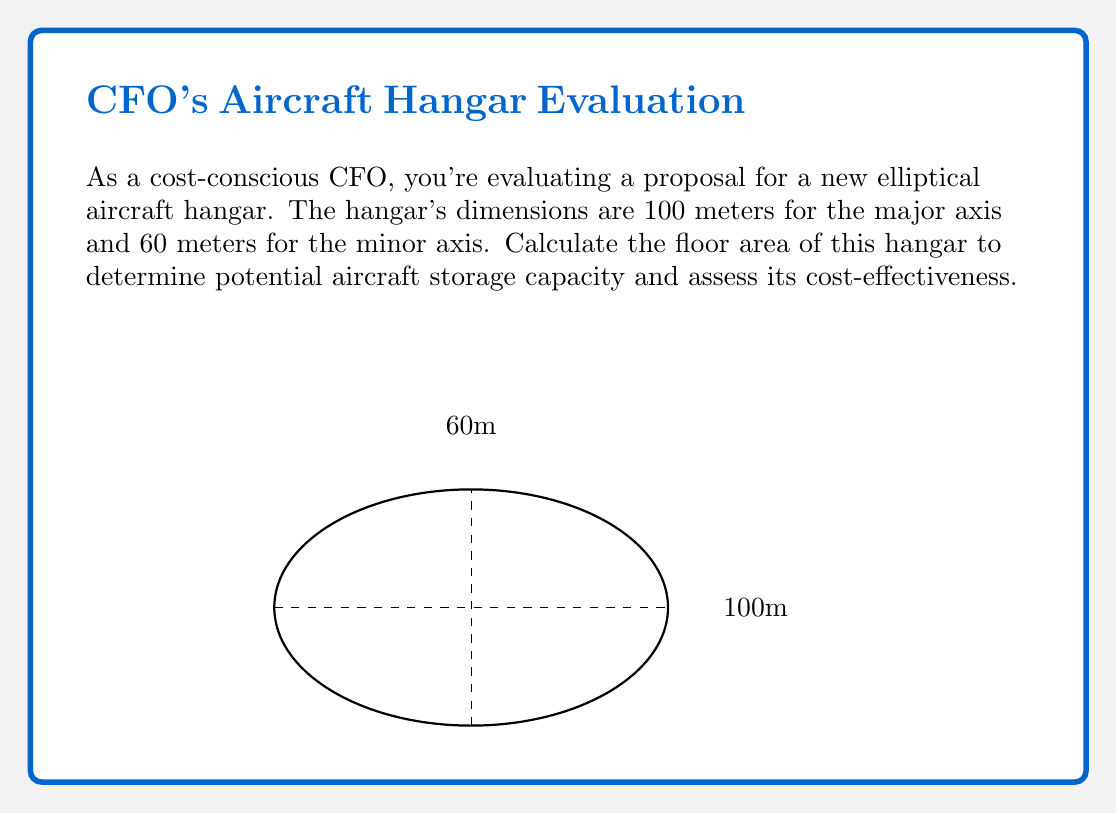Could you help me with this problem? To calculate the area of an ellipse, we use the formula:

$$A = \pi ab$$

Where:
$A$ is the area
$a$ is half the length of the major axis
$b$ is half the length of the minor axis
$\pi$ is approximately 3.14159

Step 1: Identify the values for $a$ and $b$:
$a = 100 \div 2 = 50$ meters
$b = 60 \div 2 = 30$ meters

Step 2: Substitute these values into the formula:
$$A = \pi \cdot 50 \cdot 30$$

Step 3: Calculate:
$$A = 3.14159 \cdot 50 \cdot 30 = 4712.385$$ square meters

Therefore, the floor area of the elliptical hangar is approximately 4,712.39 square meters.
Answer: 4,712.39 m² 